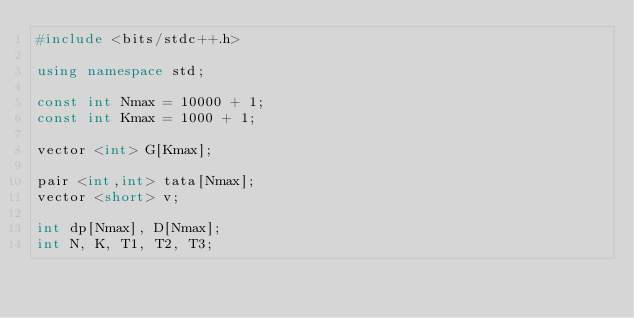<code> <loc_0><loc_0><loc_500><loc_500><_C++_>#include <bits/stdc++.h>

using namespace std;

const int Nmax = 10000 + 1;
const int Kmax = 1000 + 1;

vector <int> G[Kmax];

pair <int,int> tata[Nmax];
vector <short> v;

int dp[Nmax], D[Nmax];
int N, K, T1, T2, T3;
</code> 